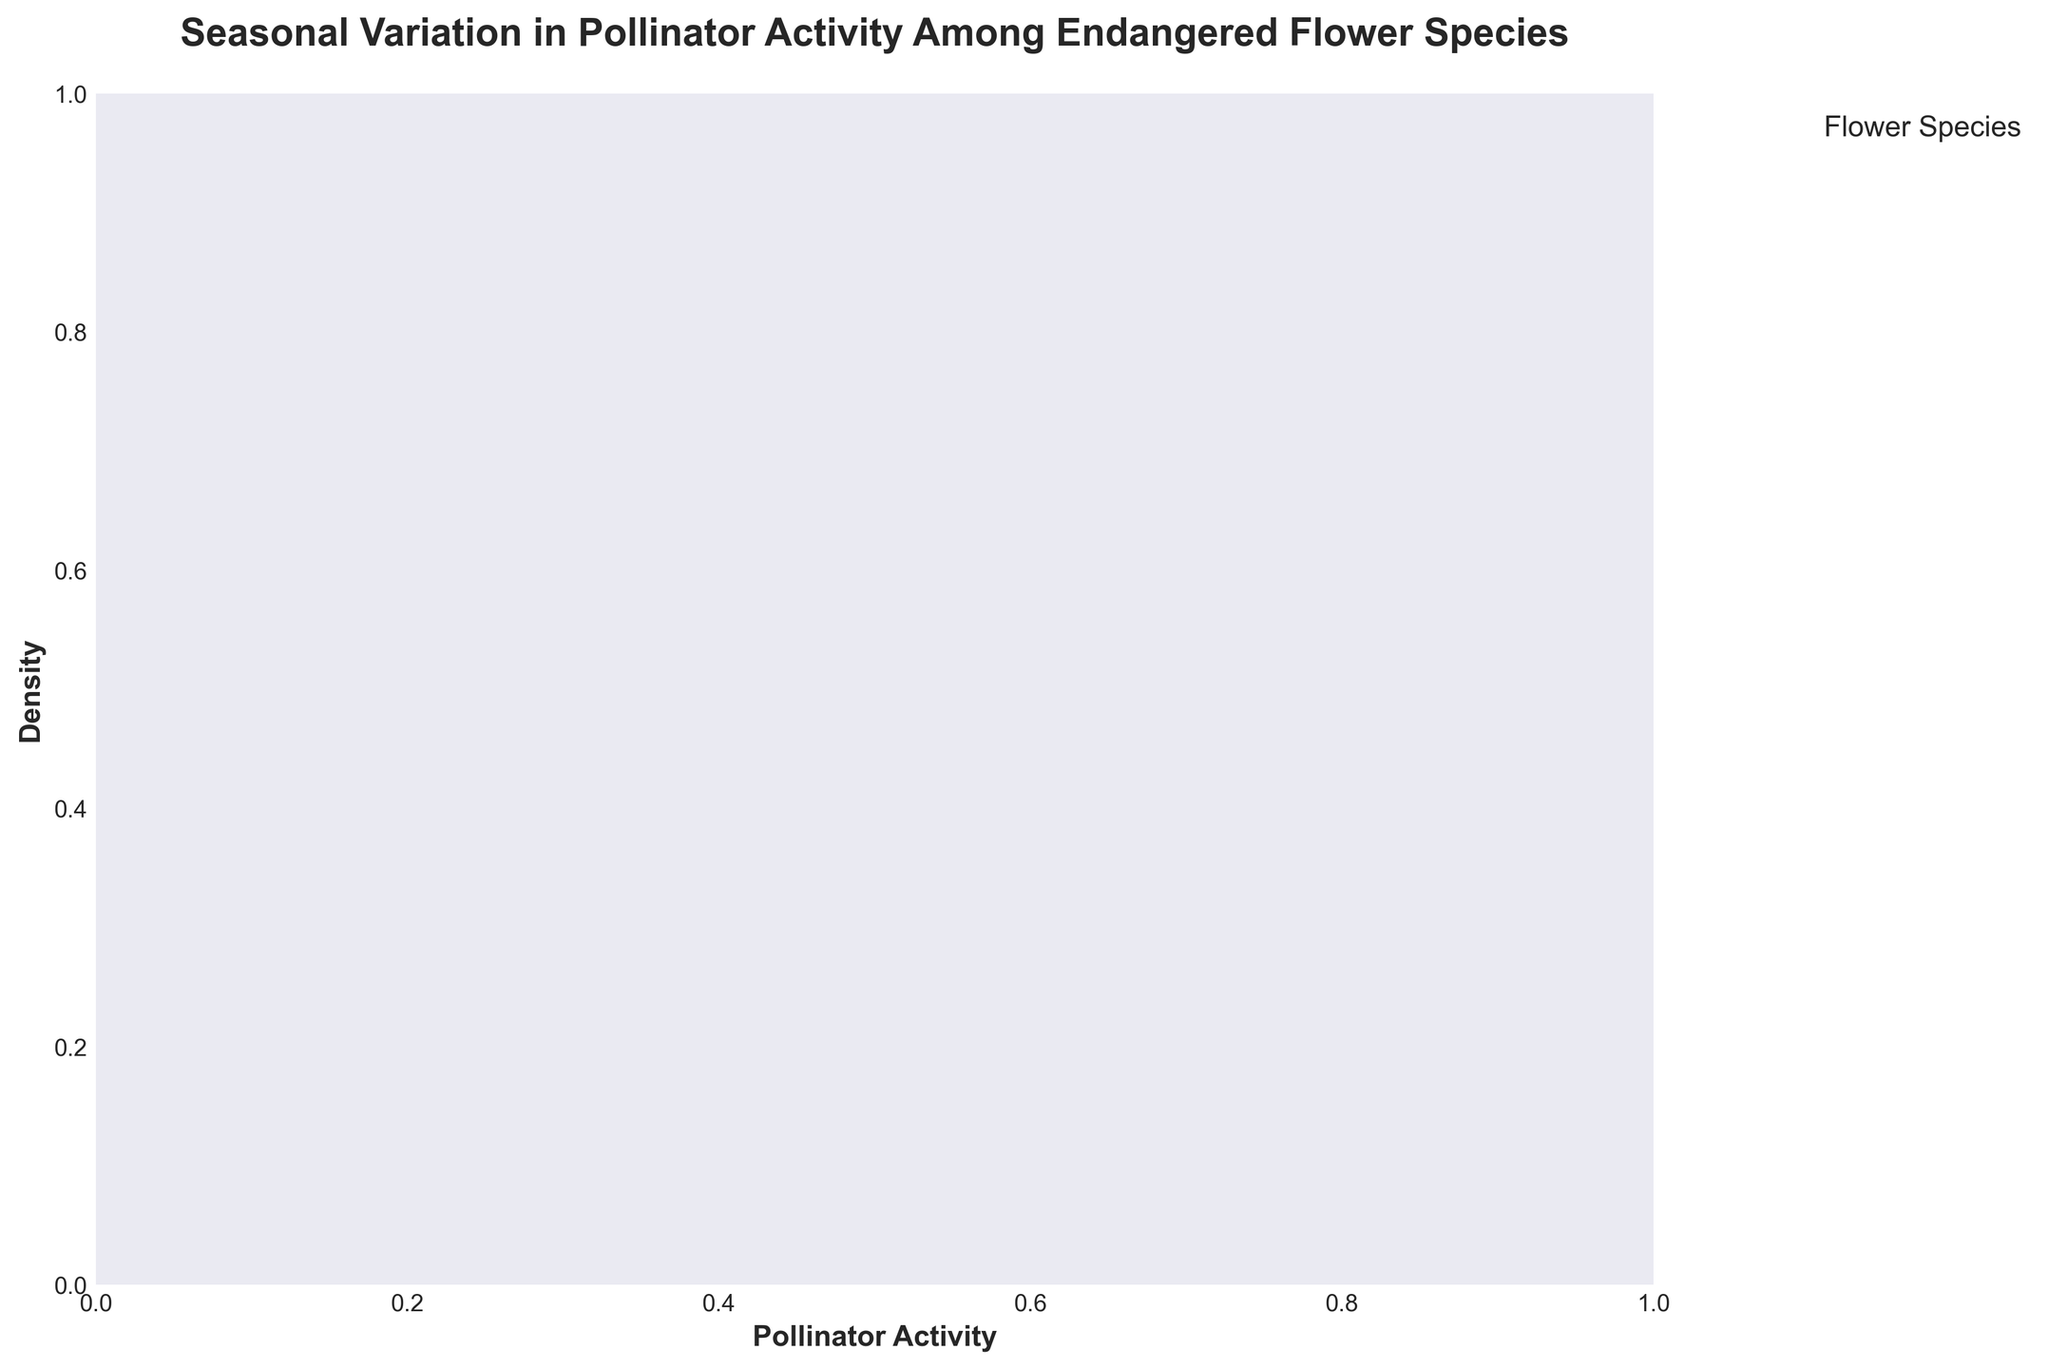What is the title of the plot? The title is written at the top of the figure and summarizes the content. It states, "Seasonal Variation in Pollinator Activity Among Endangered Flower Species."
Answer: Seasonal Variation in Pollinator Activity Among Endangered Flower Species Which season has the highest pollinator activity for the Ghost Orchid? To find this, look for the highest peak on the Ghost Orchid density curve. The Ghost Orchid has the highest pollinator activity in the spring season as indicated by its peak.
Answer: Spring Among all the flower species, which one has the lowest pollinator activity in winter? Check the density plots for all species in the winter season. The density curve for the Ghost Orchid in winter shows that its pollinator activity is zero, which is the lowest among all species.
Answer: Ghost Orchid Comparing the pollinator activities in summer, which flower species has the highest density peak? To compare, look at the summer density plots for all the flower species and identify the one with the highest peak. The peak density in the summer season appears highest for the Koki'o Flower.
Answer: Koki'o Flower In which season is the pollinator activity most similarly distributed among all flower species? Observe the density curves for each season and identify where the curves overlap the most. In fall, the density curves for all flower species are closer to each other, indicating similar distributions.
Answer: Fall What is the range of pollinator activity for the Western Prairie Fringed Orchid in spring? To find the range, examine the density plot for the Western Prairie Fringed Orchid in spring. The activity ranges from low values up to around 18, as indicated by the density curve spread.
Answer: 0 to 18 Which seasons show zero pollinator activity for at least one flower species? Look at the density plots for each season and identify if any species have a density starting at zero. Both fall and winter seasons show zero pollinator activity for at least one species.
Answer: Fall and Winter By how much does the pollinator activity for Lady's Slipper Orchid decrease from spring to winter? Determine the pollinator activity values from spring and winter density peaks for the Lady's Slipper Orchid. The decrease is from approximately 15 to 1. So, the activity decreases by 15 - 1 = 14.
Answer: 14 Which flower has the smallest variation in pollinator activity across all seasons? Evaluate the density plots across all seasons for each flower and determine which has the least variation. The Western Prairie Fringed Orchid shows the least variation across seasons.
Answer: Western Prairie Fringed Orchid For the Koki'o Flower, what is the density peak value in summer compared to spring? Compare the height of the density peak for the Koki'o Flower in summer with that in spring. The density peak in summer (12) is slightly lower compared to spring (14).
Answer: 12 in summer, 14 in spring 